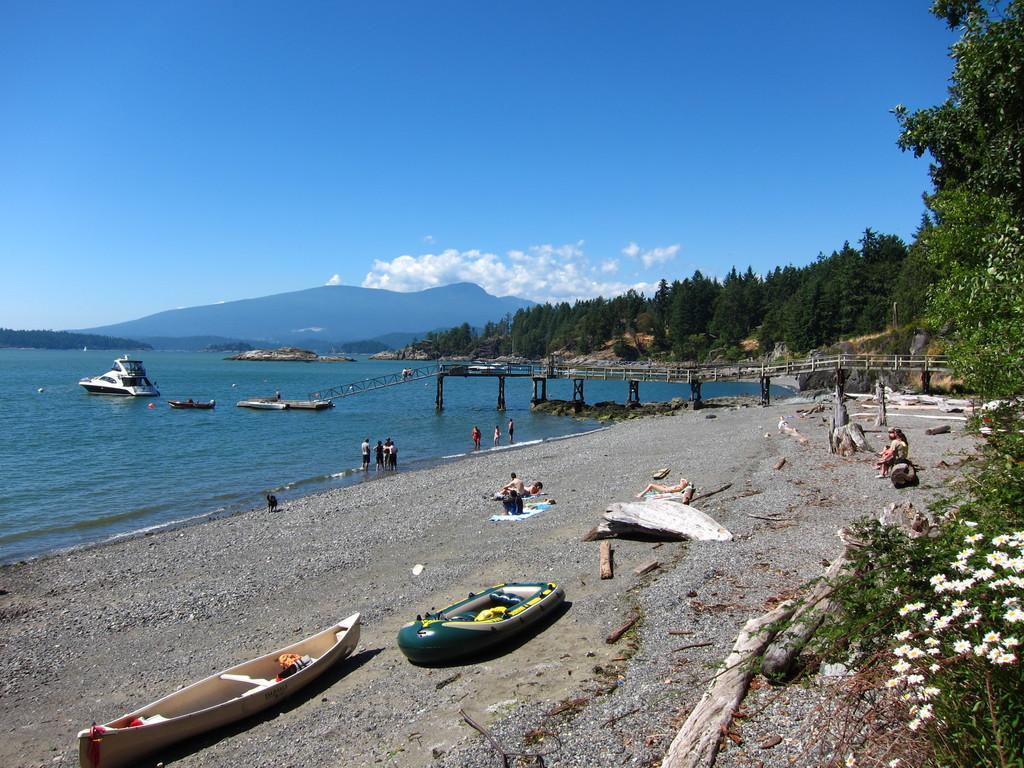Can you describe this image briefly? In this picture we can see some boat on the seaside. Behind there is a sea water and whiteboard. On the right side there is a wooden bridge. In the background there are many trees. On the top we can see the blue sky and clouds. 